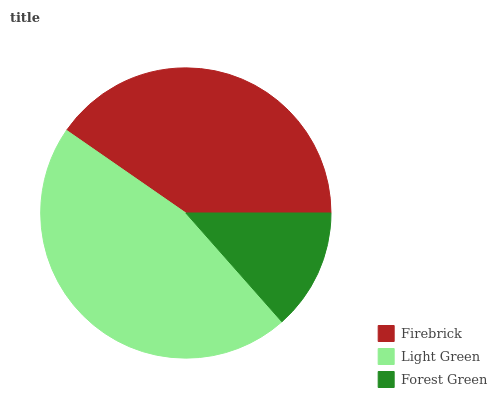Is Forest Green the minimum?
Answer yes or no. Yes. Is Light Green the maximum?
Answer yes or no. Yes. Is Light Green the minimum?
Answer yes or no. No. Is Forest Green the maximum?
Answer yes or no. No. Is Light Green greater than Forest Green?
Answer yes or no. Yes. Is Forest Green less than Light Green?
Answer yes or no. Yes. Is Forest Green greater than Light Green?
Answer yes or no. No. Is Light Green less than Forest Green?
Answer yes or no. No. Is Firebrick the high median?
Answer yes or no. Yes. Is Firebrick the low median?
Answer yes or no. Yes. Is Light Green the high median?
Answer yes or no. No. Is Forest Green the low median?
Answer yes or no. No. 